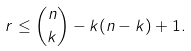Convert formula to latex. <formula><loc_0><loc_0><loc_500><loc_500>r \leq \binom { n } { k } - k ( n - k ) + 1 .</formula> 